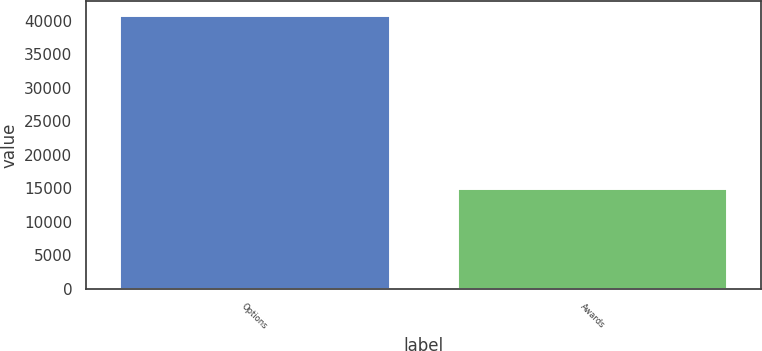Convert chart. <chart><loc_0><loc_0><loc_500><loc_500><bar_chart><fcel>Options<fcel>Awards<nl><fcel>40837<fcel>15030<nl></chart> 